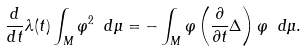<formula> <loc_0><loc_0><loc_500><loc_500>\frac { d } { d t } \lambda ( t ) \int _ { M } \varphi ^ { 2 } \ d \mu = - \int _ { M } \varphi \left ( \frac { \partial } { \partial t } \Delta \right ) \varphi \ d \mu .</formula> 